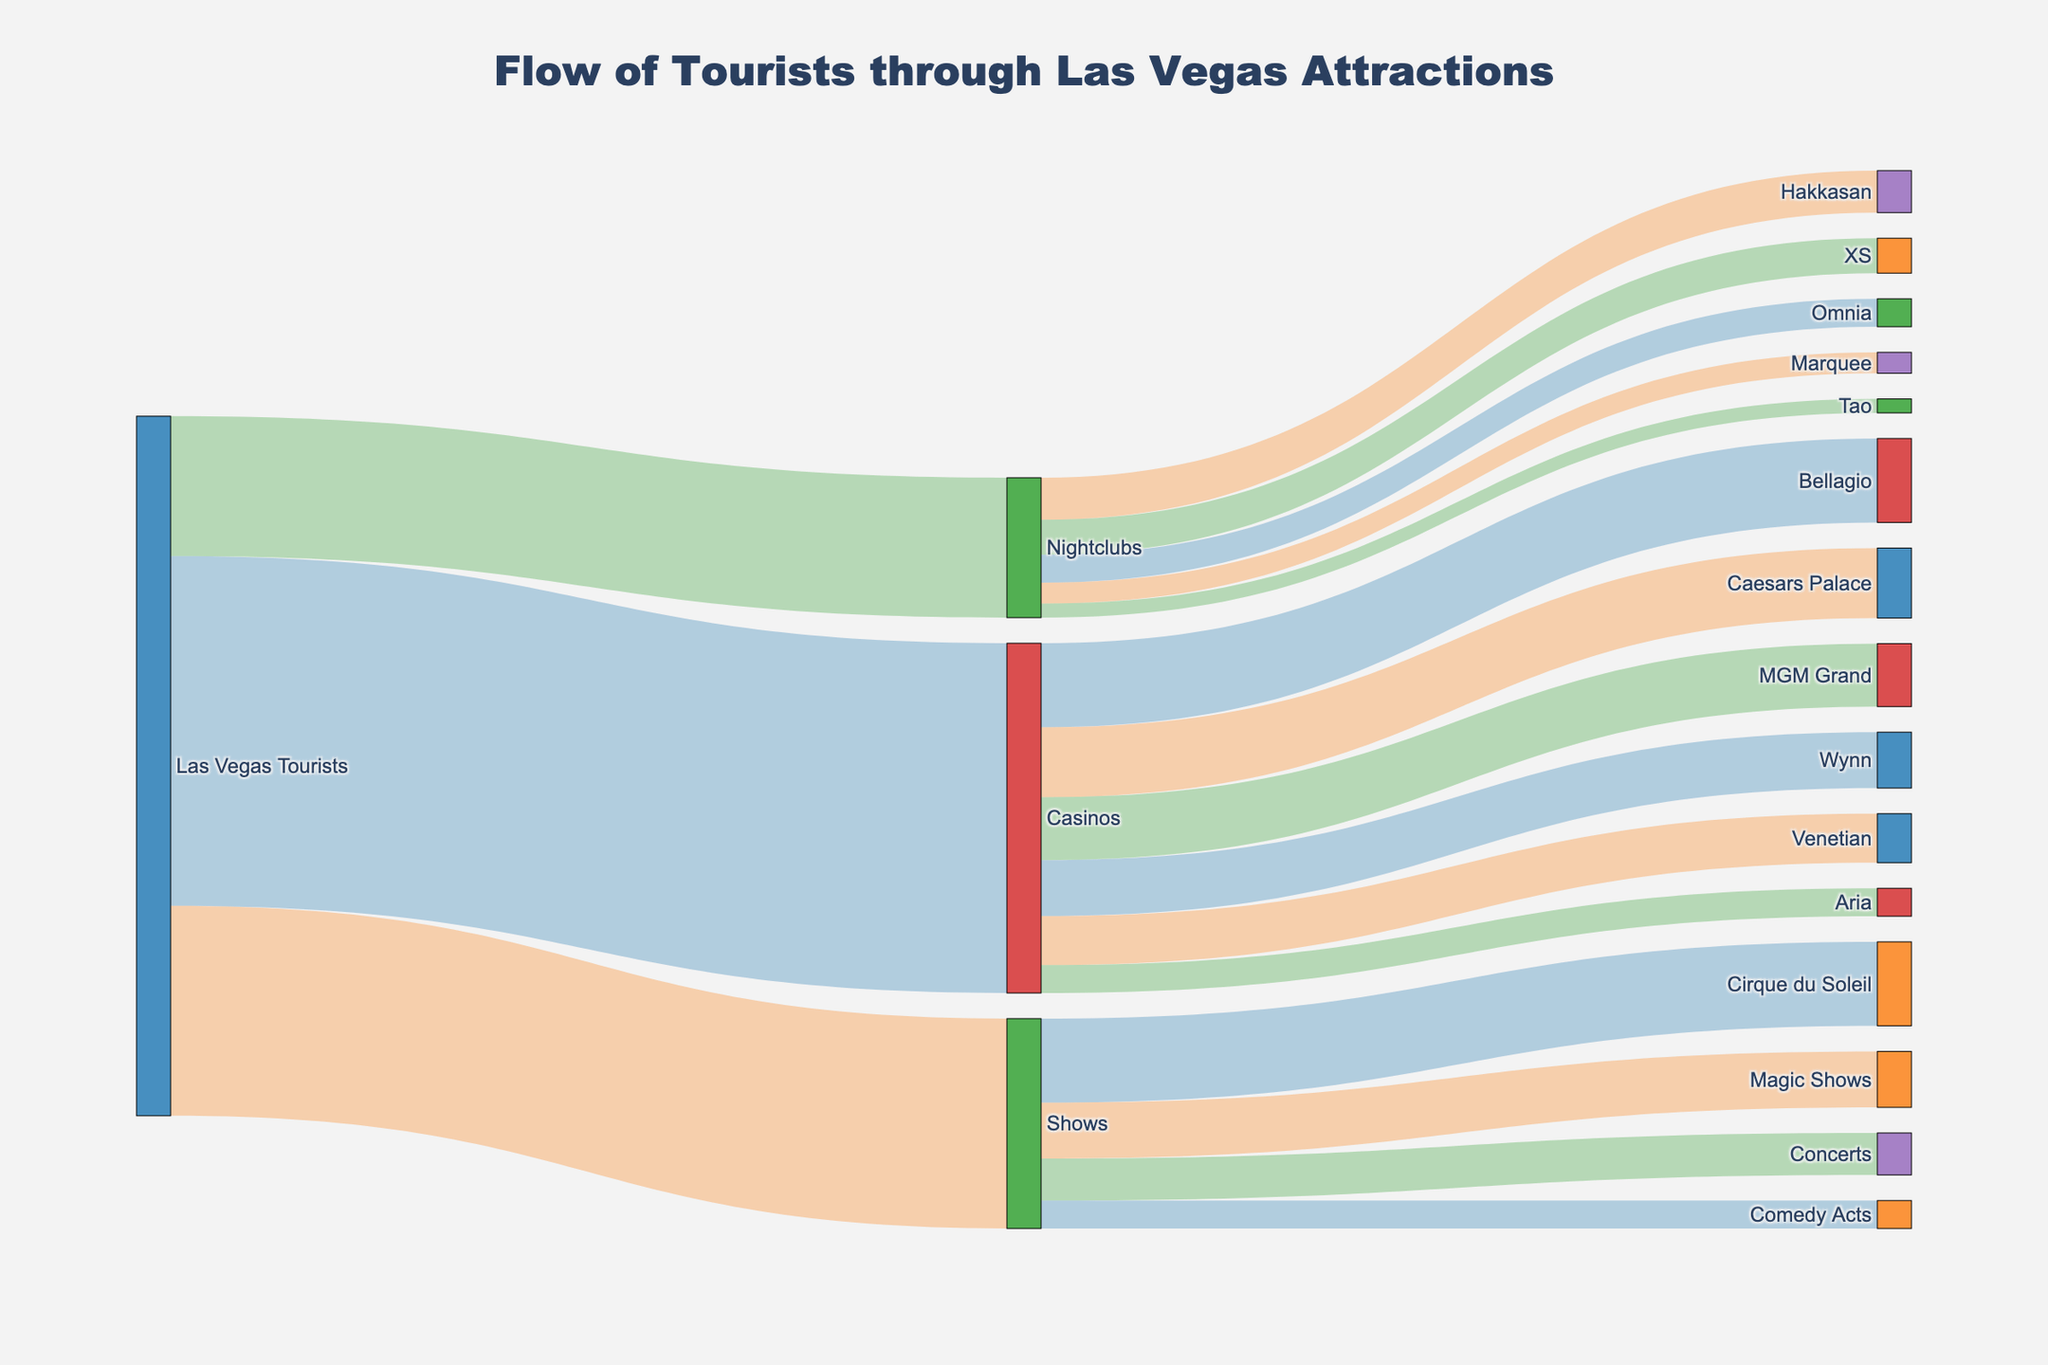Which casino receives the most tourists? The figure shows that Bellagio has the highest value among the casinos, standing at 1,200,000 tourists.
Answer: Bellagio How many tourists visit nightclubs in total? The total number of tourists visiting nightclubs can be found by adding the values of tourists visiting each nightclub: 600,000 (Hakkasan) + 500,000 (XS) + 400,000 (Omnia) + 300,000 (Marquee) + 200,000 (Tao) = 2,000,000.
Answer: 2,000,000 Which nightclub receives the least tourists? The figure indicates that Tao has the lowest value among the nightclubs, with 200,000 tourists.
Answer: Tao What is the total number of tourists visiting casinos? The total number of tourists visiting casinos is shown as 5,000,000 in the figure.
Answer: 5,000,000 Compare the number of tourists visiting Wynn and MGM Grand. The figure indicates that Wynn receives 800,000 tourists, while MGM Grand receives 900,000 tourists. Hence, MGM Grand receives 100,000 more tourists than Wynn.
Answer: MGM Grand Which attraction category receives the least tourists? By comparing the values of tourists across categories, nightclubs receive the least tourists, totaling 2,000,000 tourists.
Answer: Nightclubs What is the difference in the number of tourists between Cirque du Soleil and Comedy Acts? According to the figure, Cirque du Soleil receives 1,200,000 tourists, and Comedy Acts receive 400,000 tourists. The difference is 1,200,000 - 400,000 = 800,000 tourists.
Answer: 800,000 Compare the number of tourists visiting Caesars Palace and Aria. The figure shows that Caesars Palace receives 1,000,000 tourists, whereas Aria receives 400,000. Thus, Caesars Palace receives 600,000 more tourists than Aria.
Answer: Caesars Palace What percentage of tourists visit Hakkasan compared to those going to all nightclubs? Hakkasan receives 600,000 tourists, and the total number of tourists visiting nightclubs is 2,000,000. Hence, the percentage can be calculated as (600,000 / 2,000,000) * 100 = 30%.
Answer: 30% How does the number of tourists at Bellagio compare to the total number of tourists visiting shows? Bellagio receives 1,200,000 tourists, while the total number of tourists visiting shows is 3,000,000. Therefore, Bellagio receives 1,200,000 / 3,000,000 = 0.4 times the number of tourists visiting shows.
Answer: 1,200,000 is 40% of 3,000,000 